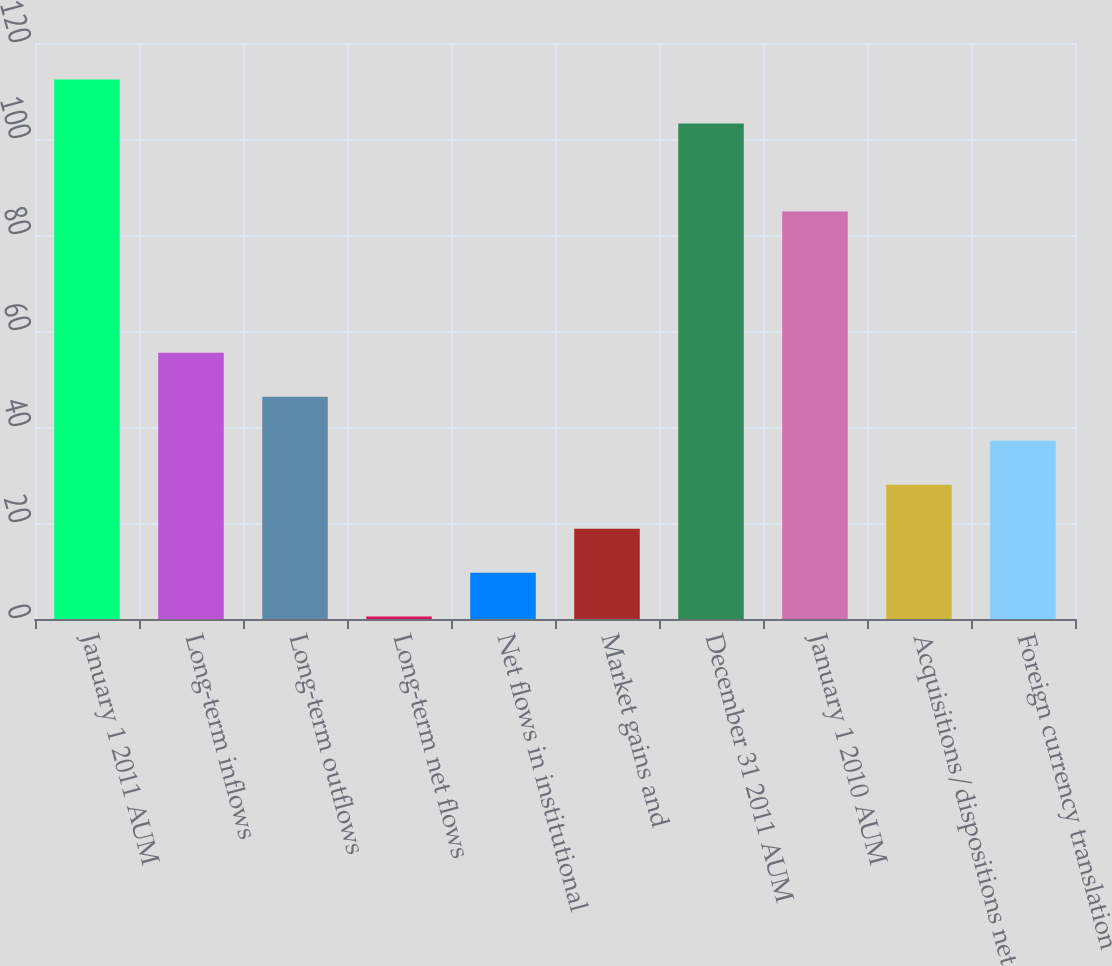Convert chart. <chart><loc_0><loc_0><loc_500><loc_500><bar_chart><fcel>January 1 2011 AUM<fcel>Long-term inflows<fcel>Long-term outflows<fcel>Long-term net flows<fcel>Net flows in institutional<fcel>Market gains and<fcel>December 31 2011 AUM<fcel>January 1 2010 AUM<fcel>Acquisitions/dispositions net<fcel>Foreign currency translation<nl><fcel>112.38<fcel>55.46<fcel>46.3<fcel>0.5<fcel>9.66<fcel>18.82<fcel>103.22<fcel>84.9<fcel>27.98<fcel>37.14<nl></chart> 